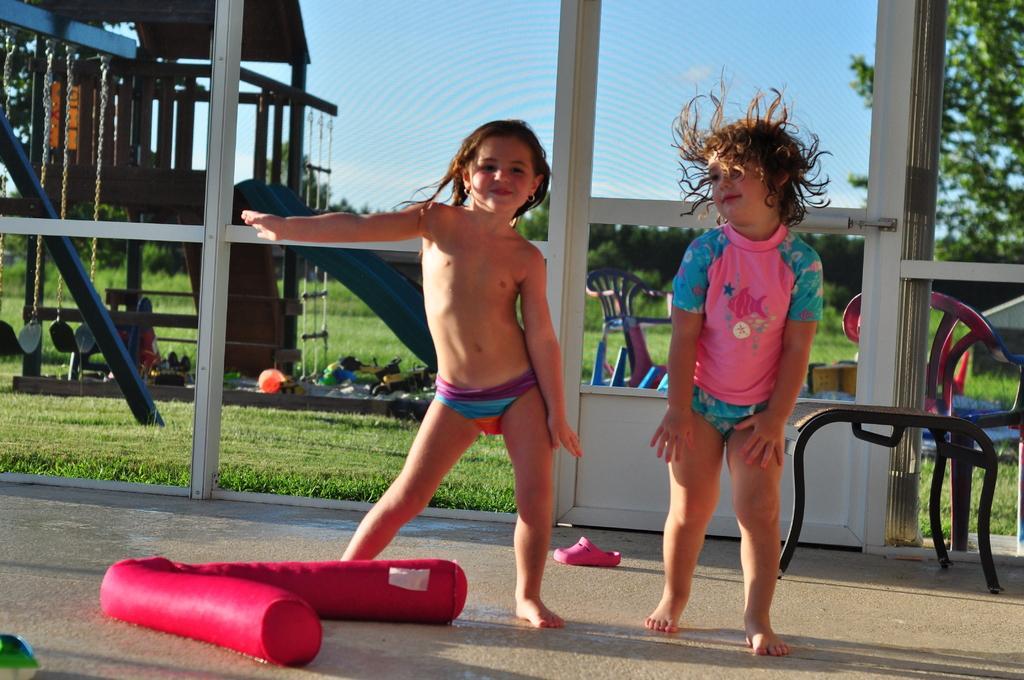Describe this image in one or two sentences. In this image I see 2 children over here and I see the red color thing over here and I see a footwear over here and I see the path. In the background I see chairs, green grass, swings, a slide trees and the blue sky. 